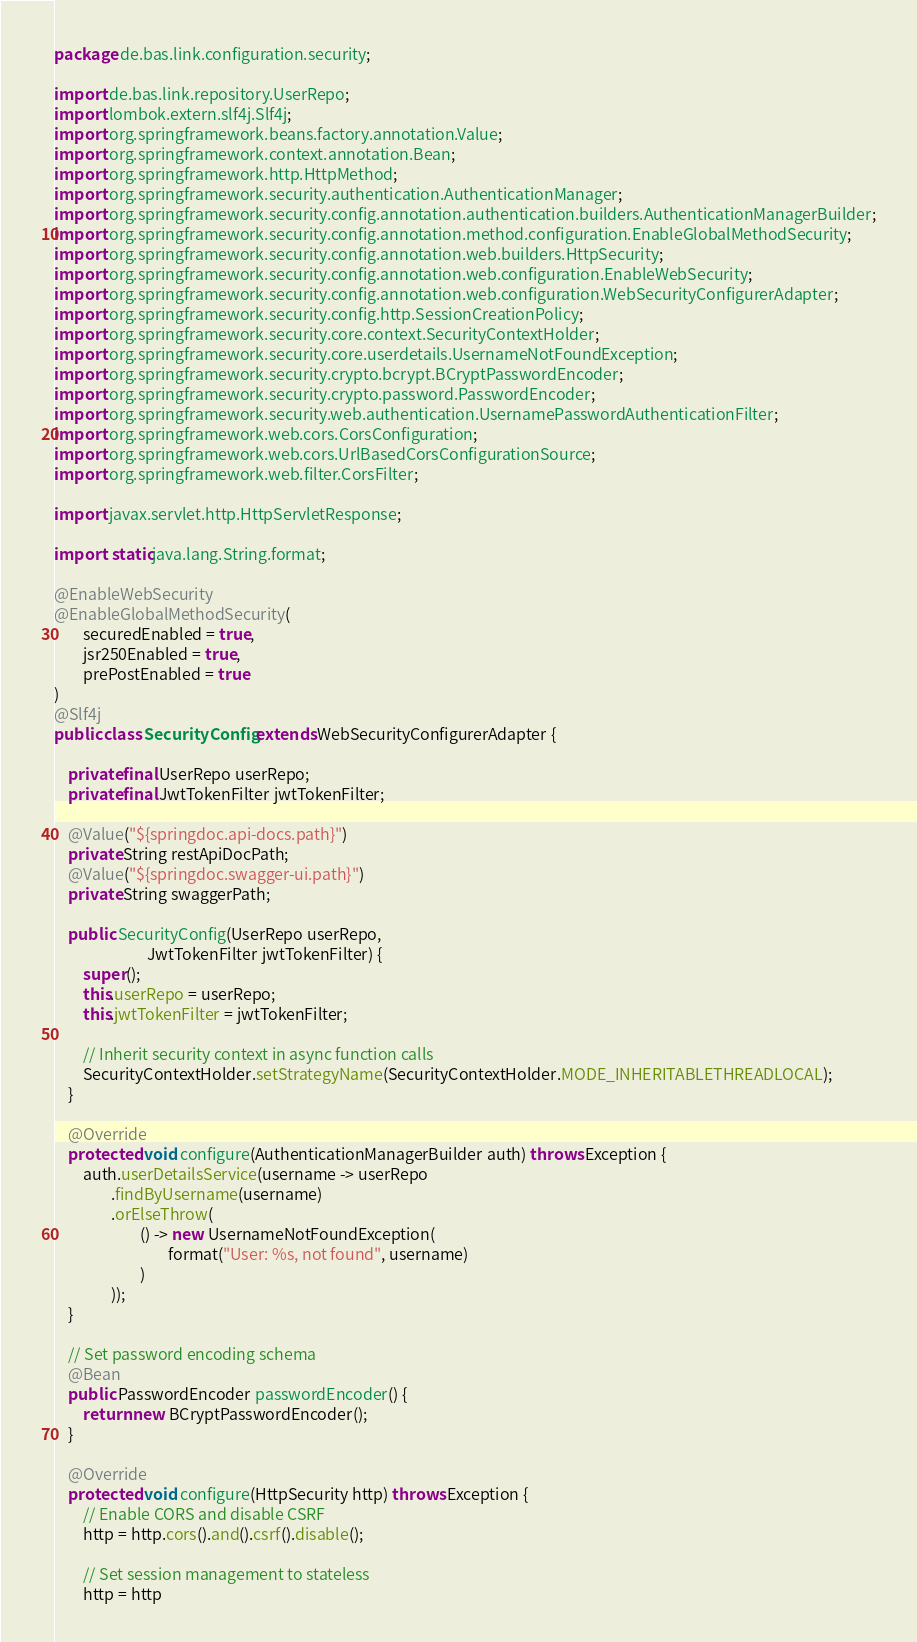Convert code to text. <code><loc_0><loc_0><loc_500><loc_500><_Java_>package de.bas.link.configuration.security;

import de.bas.link.repository.UserRepo;
import lombok.extern.slf4j.Slf4j;
import org.springframework.beans.factory.annotation.Value;
import org.springframework.context.annotation.Bean;
import org.springframework.http.HttpMethod;
import org.springframework.security.authentication.AuthenticationManager;
import org.springframework.security.config.annotation.authentication.builders.AuthenticationManagerBuilder;
import org.springframework.security.config.annotation.method.configuration.EnableGlobalMethodSecurity;
import org.springframework.security.config.annotation.web.builders.HttpSecurity;
import org.springframework.security.config.annotation.web.configuration.EnableWebSecurity;
import org.springframework.security.config.annotation.web.configuration.WebSecurityConfigurerAdapter;
import org.springframework.security.config.http.SessionCreationPolicy;
import org.springframework.security.core.context.SecurityContextHolder;
import org.springframework.security.core.userdetails.UsernameNotFoundException;
import org.springframework.security.crypto.bcrypt.BCryptPasswordEncoder;
import org.springframework.security.crypto.password.PasswordEncoder;
import org.springframework.security.web.authentication.UsernamePasswordAuthenticationFilter;
import org.springframework.web.cors.CorsConfiguration;
import org.springframework.web.cors.UrlBasedCorsConfigurationSource;
import org.springframework.web.filter.CorsFilter;

import javax.servlet.http.HttpServletResponse;

import static java.lang.String.format;

@EnableWebSecurity
@EnableGlobalMethodSecurity(
        securedEnabled = true,
        jsr250Enabled = true,
        prePostEnabled = true
)
@Slf4j
public class SecurityConfig extends WebSecurityConfigurerAdapter {

    private final UserRepo userRepo;
    private final JwtTokenFilter jwtTokenFilter;

    @Value("${springdoc.api-docs.path}")
    private String restApiDocPath;
    @Value("${springdoc.swagger-ui.path}")
    private String swaggerPath;

    public SecurityConfig(UserRepo userRepo,
                          JwtTokenFilter jwtTokenFilter) {
        super();
        this.userRepo = userRepo;
        this.jwtTokenFilter = jwtTokenFilter;

        // Inherit security context in async function calls
        SecurityContextHolder.setStrategyName(SecurityContextHolder.MODE_INHERITABLETHREADLOCAL);
    }

    @Override
    protected void configure(AuthenticationManagerBuilder auth) throws Exception {
        auth.userDetailsService(username -> userRepo
                .findByUsername(username)
                .orElseThrow(
                        () -> new UsernameNotFoundException(
                                format("User: %s, not found", username)
                        )
                ));
    }

    // Set password encoding schema
    @Bean
    public PasswordEncoder passwordEncoder() {
        return new BCryptPasswordEncoder();
    }

    @Override
    protected void configure(HttpSecurity http) throws Exception {
        // Enable CORS and disable CSRF
        http = http.cors().and().csrf().disable();

        // Set session management to stateless
        http = http</code> 